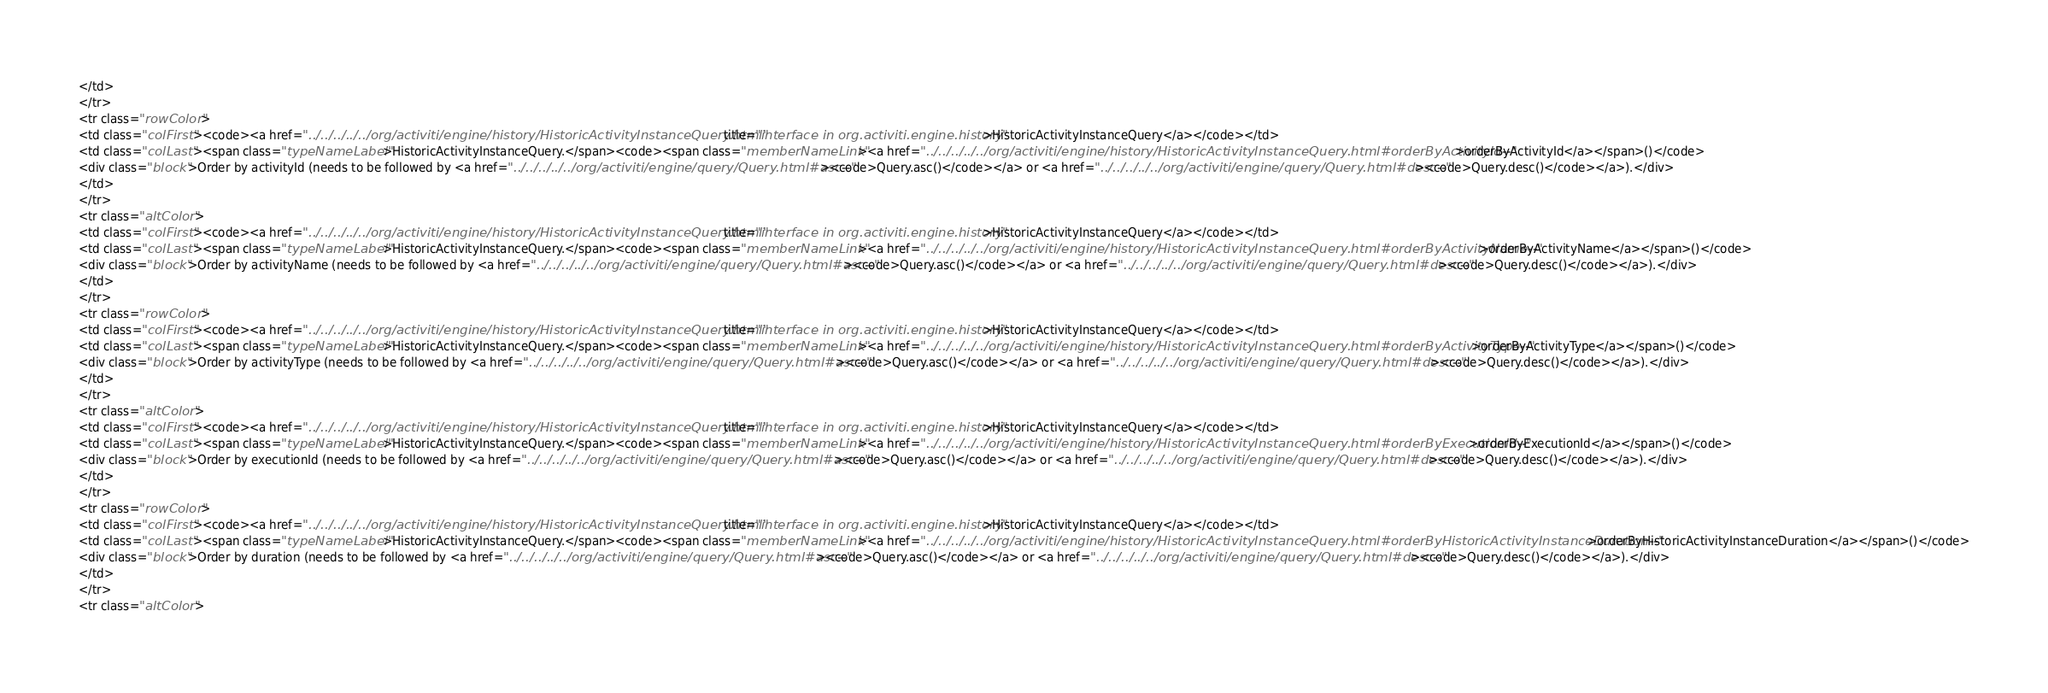Convert code to text. <code><loc_0><loc_0><loc_500><loc_500><_HTML_></td>
</tr>
<tr class="rowColor">
<td class="colFirst"><code><a href="../../../../../org/activiti/engine/history/HistoricActivityInstanceQuery.html" title="interface in org.activiti.engine.history">HistoricActivityInstanceQuery</a></code></td>
<td class="colLast"><span class="typeNameLabel">HistoricActivityInstanceQuery.</span><code><span class="memberNameLink"><a href="../../../../../org/activiti/engine/history/HistoricActivityInstanceQuery.html#orderByActivityId--">orderByActivityId</a></span>()</code>
<div class="block">Order by activityId (needs to be followed by <a href="../../../../../org/activiti/engine/query/Query.html#asc--"><code>Query.asc()</code></a> or <a href="../../../../../org/activiti/engine/query/Query.html#desc--"><code>Query.desc()</code></a>).</div>
</td>
</tr>
<tr class="altColor">
<td class="colFirst"><code><a href="../../../../../org/activiti/engine/history/HistoricActivityInstanceQuery.html" title="interface in org.activiti.engine.history">HistoricActivityInstanceQuery</a></code></td>
<td class="colLast"><span class="typeNameLabel">HistoricActivityInstanceQuery.</span><code><span class="memberNameLink"><a href="../../../../../org/activiti/engine/history/HistoricActivityInstanceQuery.html#orderByActivityName--">orderByActivityName</a></span>()</code>
<div class="block">Order by activityName (needs to be followed by <a href="../../../../../org/activiti/engine/query/Query.html#asc--"><code>Query.asc()</code></a> or <a href="../../../../../org/activiti/engine/query/Query.html#desc--"><code>Query.desc()</code></a>).</div>
</td>
</tr>
<tr class="rowColor">
<td class="colFirst"><code><a href="../../../../../org/activiti/engine/history/HistoricActivityInstanceQuery.html" title="interface in org.activiti.engine.history">HistoricActivityInstanceQuery</a></code></td>
<td class="colLast"><span class="typeNameLabel">HistoricActivityInstanceQuery.</span><code><span class="memberNameLink"><a href="../../../../../org/activiti/engine/history/HistoricActivityInstanceQuery.html#orderByActivityType--">orderByActivityType</a></span>()</code>
<div class="block">Order by activityType (needs to be followed by <a href="../../../../../org/activiti/engine/query/Query.html#asc--"><code>Query.asc()</code></a> or <a href="../../../../../org/activiti/engine/query/Query.html#desc--"><code>Query.desc()</code></a>).</div>
</td>
</tr>
<tr class="altColor">
<td class="colFirst"><code><a href="../../../../../org/activiti/engine/history/HistoricActivityInstanceQuery.html" title="interface in org.activiti.engine.history">HistoricActivityInstanceQuery</a></code></td>
<td class="colLast"><span class="typeNameLabel">HistoricActivityInstanceQuery.</span><code><span class="memberNameLink"><a href="../../../../../org/activiti/engine/history/HistoricActivityInstanceQuery.html#orderByExecutionId--">orderByExecutionId</a></span>()</code>
<div class="block">Order by executionId (needs to be followed by <a href="../../../../../org/activiti/engine/query/Query.html#asc--"><code>Query.asc()</code></a> or <a href="../../../../../org/activiti/engine/query/Query.html#desc--"><code>Query.desc()</code></a>).</div>
</td>
</tr>
<tr class="rowColor">
<td class="colFirst"><code><a href="../../../../../org/activiti/engine/history/HistoricActivityInstanceQuery.html" title="interface in org.activiti.engine.history">HistoricActivityInstanceQuery</a></code></td>
<td class="colLast"><span class="typeNameLabel">HistoricActivityInstanceQuery.</span><code><span class="memberNameLink"><a href="../../../../../org/activiti/engine/history/HistoricActivityInstanceQuery.html#orderByHistoricActivityInstanceDuration--">orderByHistoricActivityInstanceDuration</a></span>()</code>
<div class="block">Order by duration (needs to be followed by <a href="../../../../../org/activiti/engine/query/Query.html#asc--"><code>Query.asc()</code></a> or <a href="../../../../../org/activiti/engine/query/Query.html#desc--"><code>Query.desc()</code></a>).</div>
</td>
</tr>
<tr class="altColor"></code> 